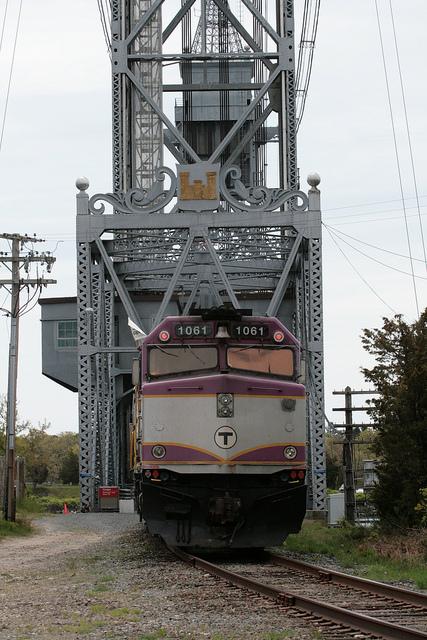Is the train facing the camera?
Quick response, please. Yes. Is this a train station?
Short answer required. No. Is the train moving?
Quick response, please. Yes. 